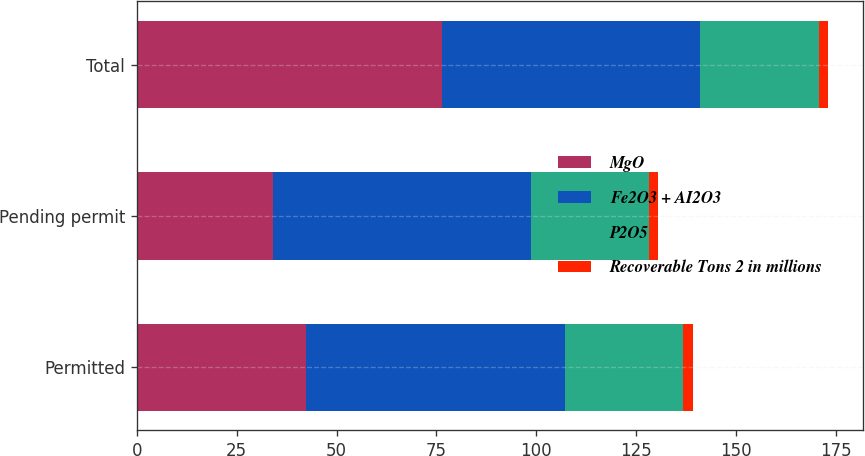<chart> <loc_0><loc_0><loc_500><loc_500><stacked_bar_chart><ecel><fcel>Permitted<fcel>Pending permit<fcel>Total<nl><fcel>MgO<fcel>42.4<fcel>34<fcel>76.4<nl><fcel>Fe2O3 + AI2O3<fcel>64.79<fcel>64.57<fcel>64.7<nl><fcel>P2O5<fcel>29.65<fcel>29.55<fcel>29.61<nl><fcel>Recoverable Tons 2 in millions<fcel>2.35<fcel>2.39<fcel>2.37<nl></chart> 